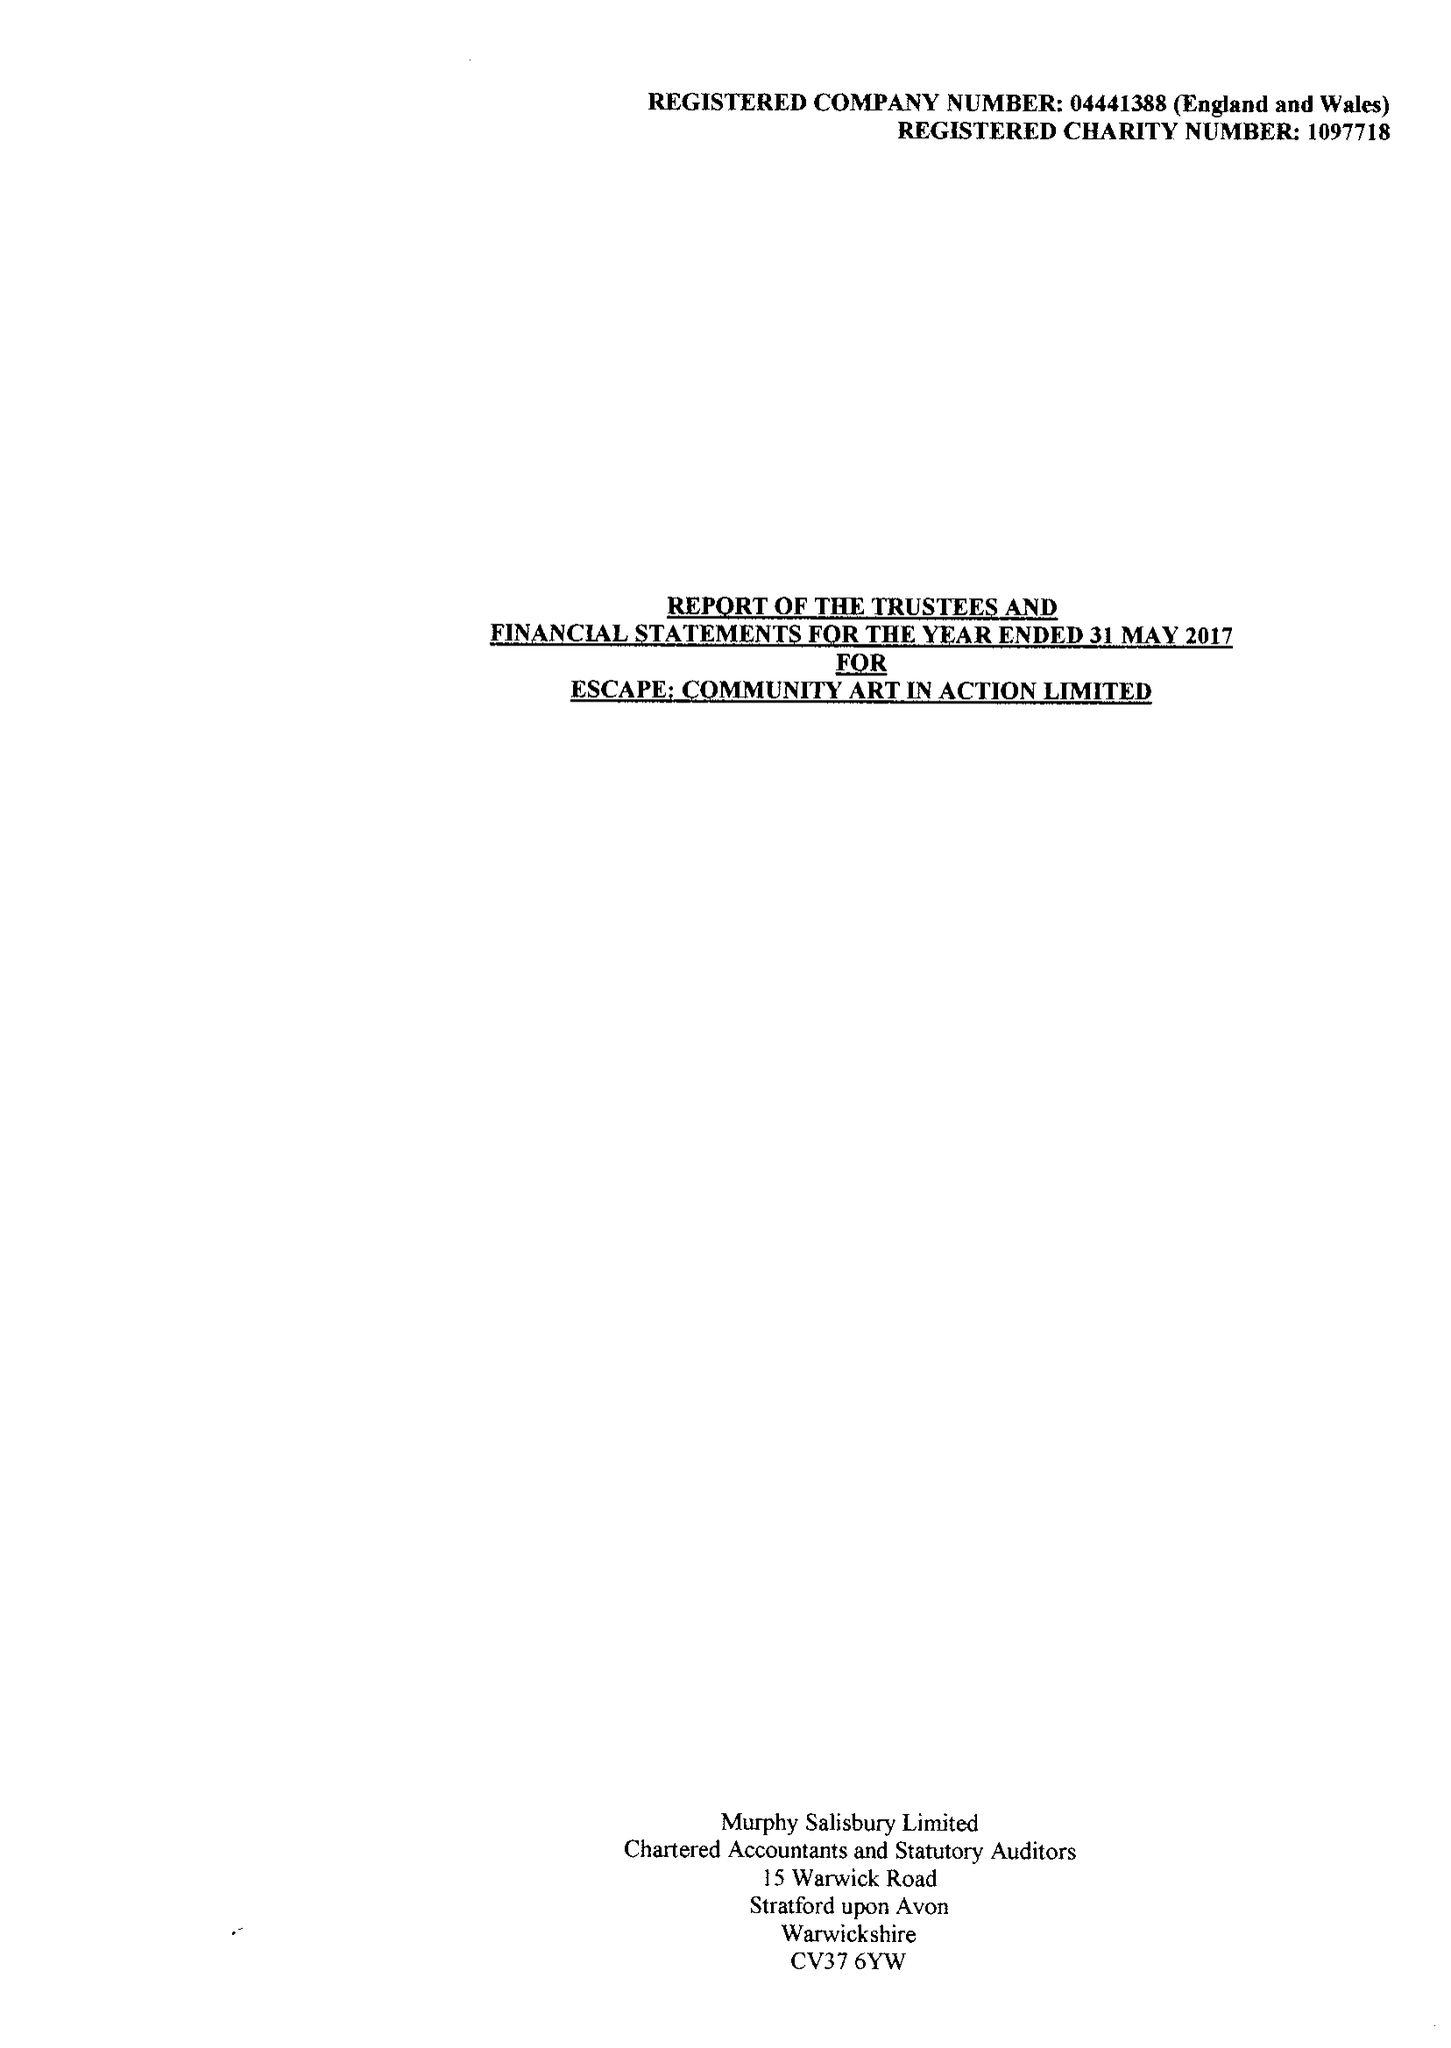What is the value for the spending_annually_in_british_pounds?
Answer the question using a single word or phrase. 284365.00 